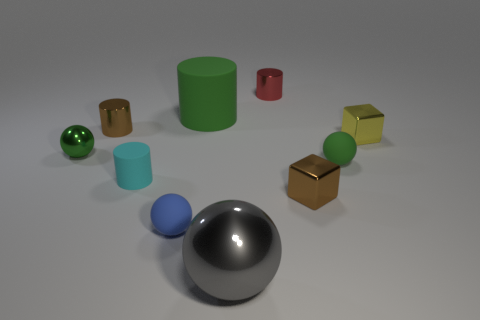There is a green metallic object that is the same size as the blue sphere; what is its shape?
Your response must be concise. Sphere. Is the number of tiny rubber objects behind the cyan rubber object the same as the number of green rubber cylinders to the left of the brown metal cylinder?
Give a very brief answer. No. What is the size of the rubber thing that is behind the green sphere left of the big matte cylinder?
Keep it short and to the point. Large. Are there any yellow shiny blocks of the same size as the green cylinder?
Your answer should be very brief. No. What is the color of the cylinder that is made of the same material as the tiny cyan thing?
Provide a succinct answer. Green. Is the number of small things less than the number of big green matte cylinders?
Make the answer very short. No. There is a cylinder that is both behind the tiny yellow cube and left of the small blue matte thing; what is its material?
Provide a succinct answer. Metal. There is a tiny block that is in front of the yellow block; is there a brown cube that is in front of it?
Provide a short and direct response. No. How many other shiny cylinders have the same color as the large cylinder?
Make the answer very short. 0. What material is the other ball that is the same color as the small metal sphere?
Your response must be concise. Rubber. 